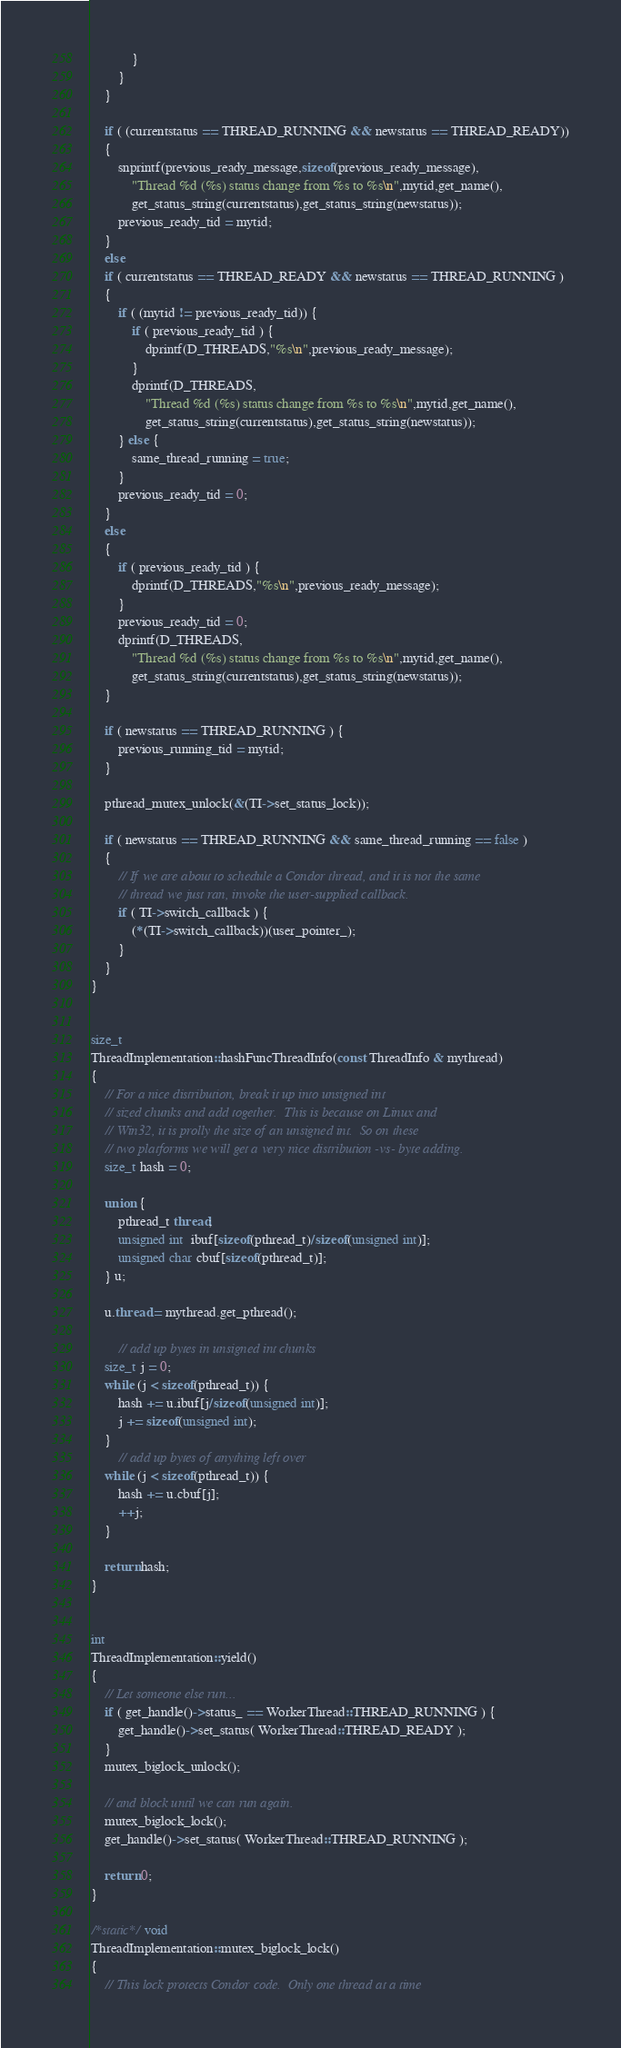<code> <loc_0><loc_0><loc_500><loc_500><_C++_>			}
		}
	}

	if ( (currentstatus == THREAD_RUNNING && newstatus == THREAD_READY))
	{
		snprintf(previous_ready_message,sizeof(previous_ready_message),
			"Thread %d (%s) status change from %s to %s\n",mytid,get_name(),
			get_status_string(currentstatus),get_status_string(newstatus));
		previous_ready_tid = mytid;
	} 
	else 
	if ( currentstatus == THREAD_READY && newstatus == THREAD_RUNNING ) 
	{
		if ( (mytid != previous_ready_tid)) {
			if ( previous_ready_tid ) {
				dprintf(D_THREADS,"%s\n",previous_ready_message);		
			}
			dprintf(D_THREADS,
				"Thread %d (%s) status change from %s to %s\n",mytid,get_name(),
				get_status_string(currentstatus),get_status_string(newstatus));
		} else {
			same_thread_running = true;
		}
		previous_ready_tid = 0;
	}
	else 
	{
		if ( previous_ready_tid ) {
			dprintf(D_THREADS,"%s\n",previous_ready_message);		
		}
		previous_ready_tid = 0;
		dprintf(D_THREADS,
			"Thread %d (%s) status change from %s to %s\n",mytid,get_name(),
			get_status_string(currentstatus),get_status_string(newstatus));
	}

	if ( newstatus == THREAD_RUNNING ) {
		previous_running_tid = mytid;
	}

	pthread_mutex_unlock(&(TI->set_status_lock));

	if ( newstatus == THREAD_RUNNING && same_thread_running == false )
	{
		// If we are about to schedule a Condor thread, and it is not the same 
		// thread we just ran, invoke the user-supplied callback.
		if ( TI->switch_callback ) {
			(*(TI->switch_callback))(user_pointer_);	
		}
	}
}


size_t
ThreadImplementation::hashFuncThreadInfo(const ThreadInfo & mythread)
{
	// For a nice distribution, break it up into unsigned int 
	// sized chunks and add together.  This is because on Linux and 
	// Win32, it is prolly the size of an unsigned int.  So on these
	// two platforms we will get a very nice distribution -vs- byte adding.
	size_t hash = 0;

	union {
		pthread_t thread;
		unsigned int  ibuf[sizeof(pthread_t)/sizeof(unsigned int)];
		unsigned char cbuf[sizeof(pthread_t)];
	} u;

	u.thread = mythread.get_pthread();

		// add up bytes in unsigned int chunks
	size_t j = 0;
	while (j < sizeof(pthread_t)) {
		hash += u.ibuf[j/sizeof(unsigned int)];
		j += sizeof(unsigned int);
	}
		// add up bytes of anything left over
	while (j < sizeof(pthread_t)) {
		hash += u.cbuf[j];
		++j;
	}

	return hash;
}


int
ThreadImplementation::yield()
{
	// Let someone else run...
	if ( get_handle()->status_ == WorkerThread::THREAD_RUNNING ) {
		get_handle()->set_status( WorkerThread::THREAD_READY );
	}
	mutex_biglock_unlock();

	// and block until we can run again.
	mutex_biglock_lock();
	get_handle()->set_status( WorkerThread::THREAD_RUNNING );

	return 0;
}

/*static*/ void
ThreadImplementation::mutex_biglock_lock()
{
	// This lock protects Condor code.  Only one thread at a time</code> 